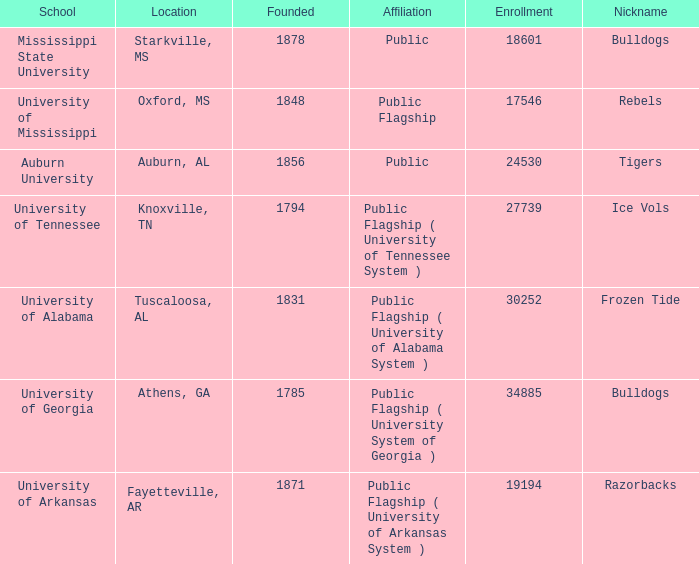What is the nickname of the University of Alabama? Frozen Tide. 